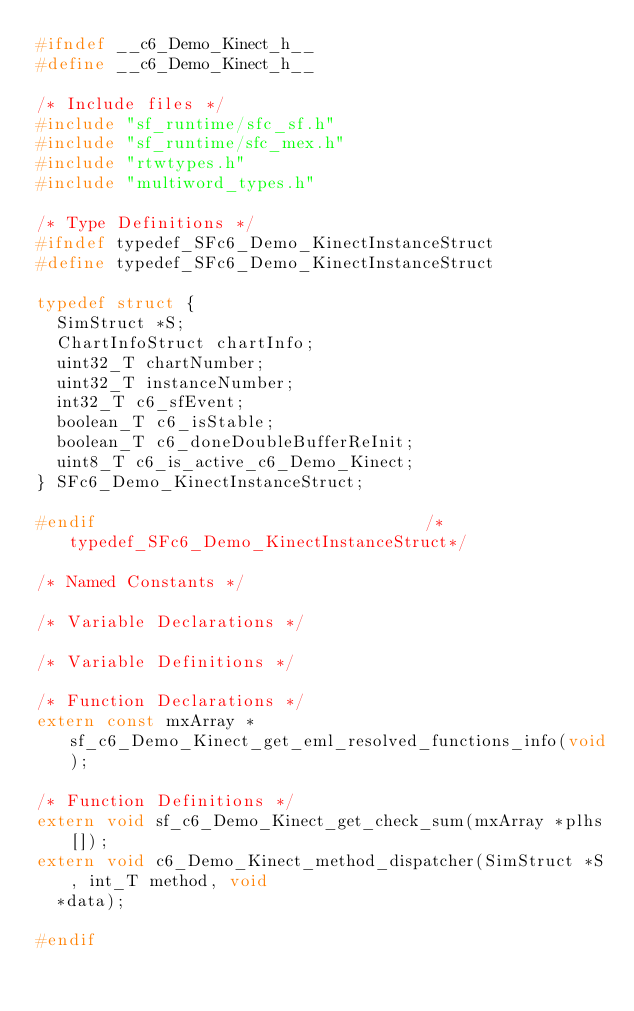<code> <loc_0><loc_0><loc_500><loc_500><_C_>#ifndef __c6_Demo_Kinect_h__
#define __c6_Demo_Kinect_h__

/* Include files */
#include "sf_runtime/sfc_sf.h"
#include "sf_runtime/sfc_mex.h"
#include "rtwtypes.h"
#include "multiword_types.h"

/* Type Definitions */
#ifndef typedef_SFc6_Demo_KinectInstanceStruct
#define typedef_SFc6_Demo_KinectInstanceStruct

typedef struct {
  SimStruct *S;
  ChartInfoStruct chartInfo;
  uint32_T chartNumber;
  uint32_T instanceNumber;
  int32_T c6_sfEvent;
  boolean_T c6_isStable;
  boolean_T c6_doneDoubleBufferReInit;
  uint8_T c6_is_active_c6_Demo_Kinect;
} SFc6_Demo_KinectInstanceStruct;

#endif                                 /*typedef_SFc6_Demo_KinectInstanceStruct*/

/* Named Constants */

/* Variable Declarations */

/* Variable Definitions */

/* Function Declarations */
extern const mxArray *sf_c6_Demo_Kinect_get_eml_resolved_functions_info(void);

/* Function Definitions */
extern void sf_c6_Demo_Kinect_get_check_sum(mxArray *plhs[]);
extern void c6_Demo_Kinect_method_dispatcher(SimStruct *S, int_T method, void
  *data);

#endif
</code> 